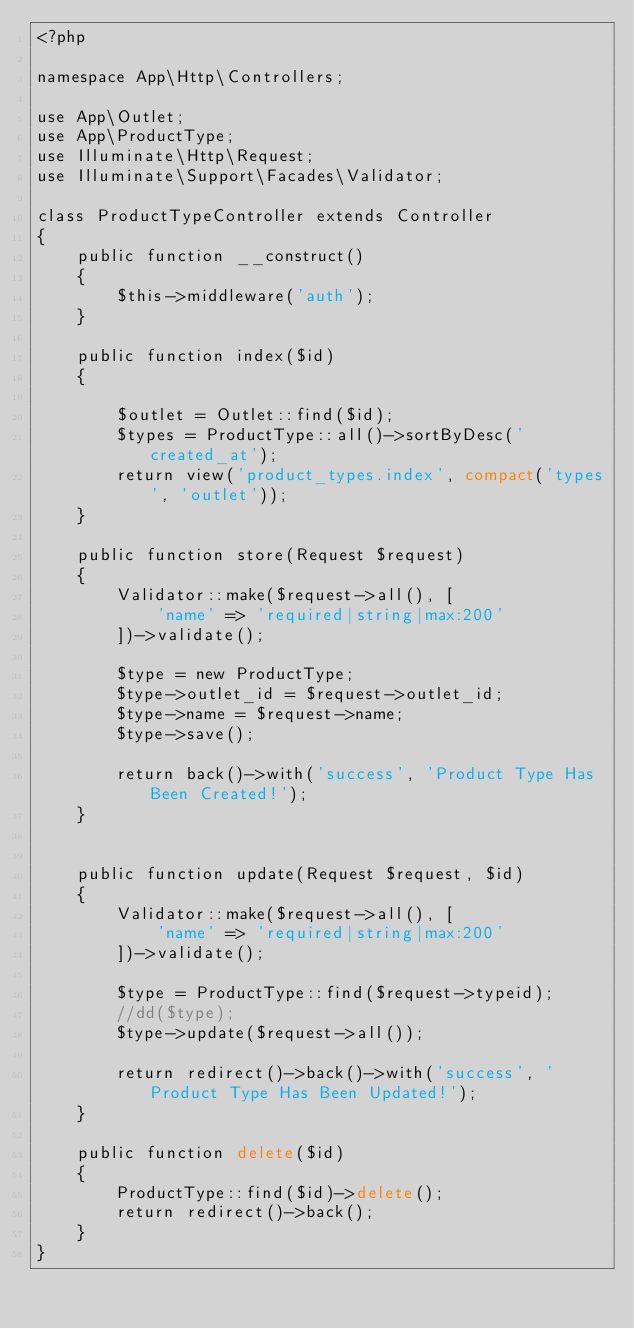<code> <loc_0><loc_0><loc_500><loc_500><_PHP_><?php

namespace App\Http\Controllers;

use App\Outlet;
use App\ProductType;
use Illuminate\Http\Request;
use Illuminate\Support\Facades\Validator;

class ProductTypeController extends Controller
{
	public function __construct()
    {
        $this->middleware('auth');
    }
    
	public function index($id)
	{

		$outlet = Outlet::find($id);
		$types = ProductType::all()->sortByDesc('created_at');
		return view('product_types.index', compact('types', 'outlet'));
	}

	public function store(Request $request)
	{
		Validator::make($request->all(), [
			'name' => 'required|string|max:200'
		])->validate();

		$type = new ProductType;
		$type->outlet_id = $request->outlet_id;
		$type->name = $request->name;
		$type->save();

		return back()->with('success', 'Product Type Has Been Created!');
	}


	public function update(Request $request, $id)
	{
		Validator::make($request->all(), [
			'name' => 'required|string|max:200'
		])->validate();

		$type = ProductType::find($request->typeid);
		//dd($type);
		$type->update($request->all());

		return redirect()->back()->with('success', 'Product Type Has Been Updated!');
	}

	public function delete($id)
	{
		ProductType::find($id)->delete();
		return redirect()->back();
	}
}
</code> 